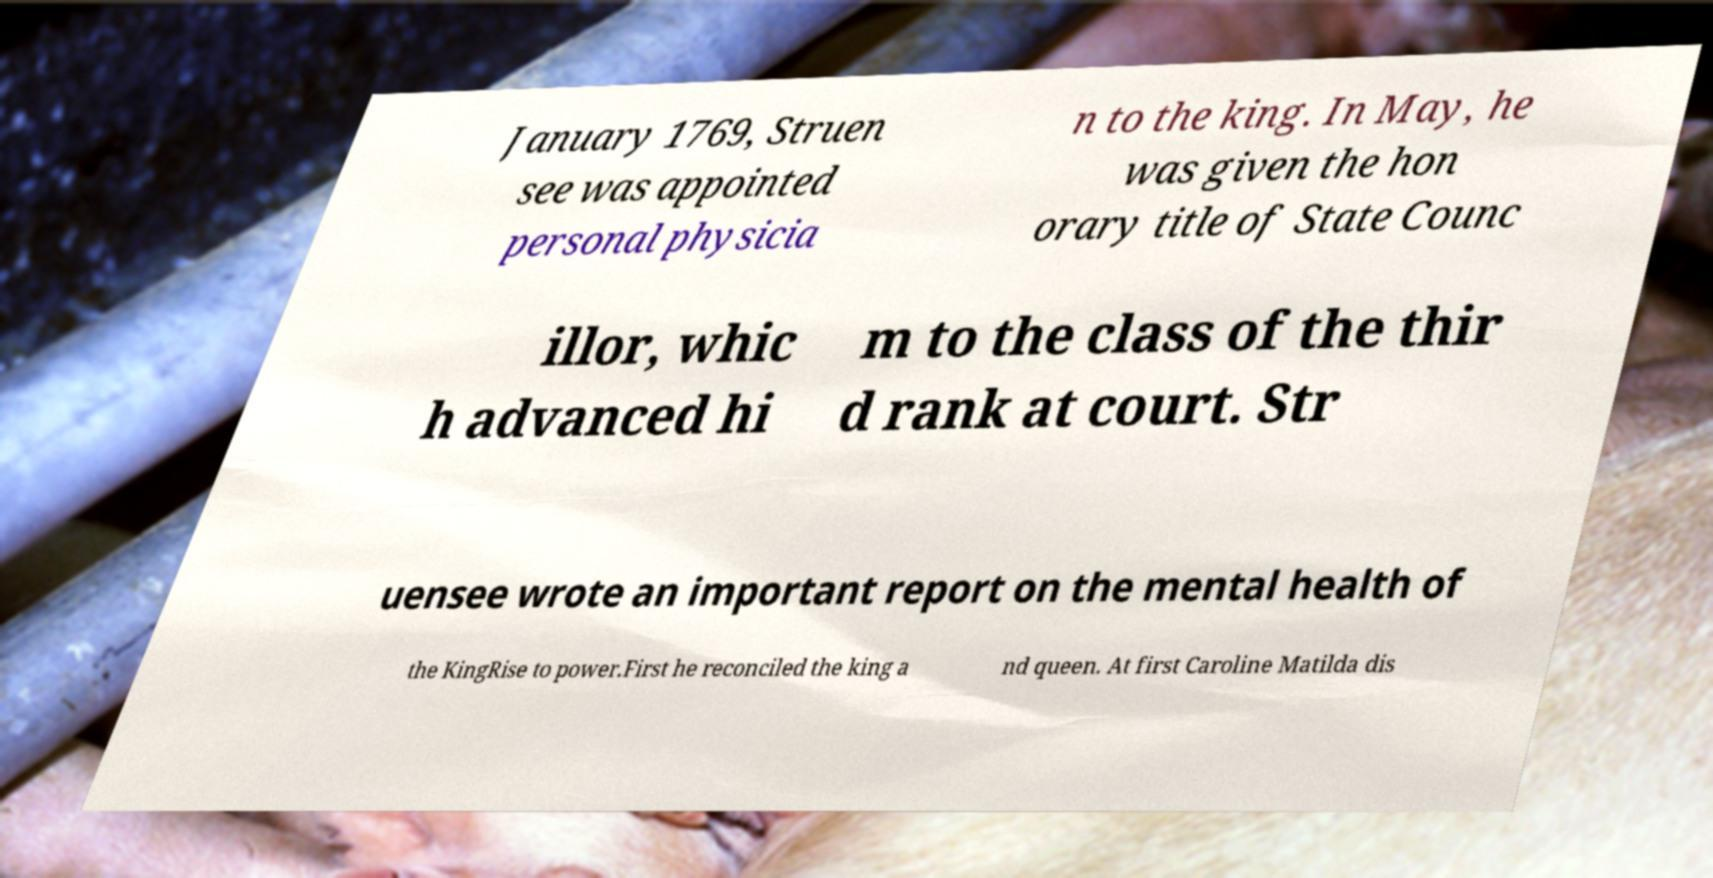What messages or text are displayed in this image? I need them in a readable, typed format. January 1769, Struen see was appointed personal physicia n to the king. In May, he was given the hon orary title of State Counc illor, whic h advanced hi m to the class of the thir d rank at court. Str uensee wrote an important report on the mental health of the KingRise to power.First he reconciled the king a nd queen. At first Caroline Matilda dis 